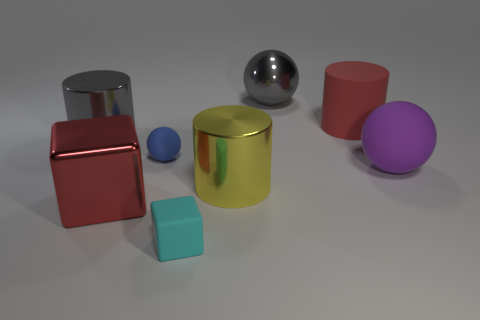Is the number of small rubber spheres that are to the left of the large red metallic thing less than the number of big gray shiny balls that are right of the red cylinder?
Offer a terse response. No. What is the material of the cube on the right side of the blue ball?
Make the answer very short. Rubber. The cylinder that is the same color as the big block is what size?
Provide a short and direct response. Large. Are there any yellow shiny cylinders of the same size as the purple sphere?
Your answer should be very brief. Yes. There is a blue rubber object; does it have the same shape as the gray thing that is left of the tiny blue rubber thing?
Make the answer very short. No. Is the size of the red object behind the large purple matte ball the same as the gray metal thing that is on the left side of the red shiny object?
Offer a terse response. Yes. What number of other things are the same shape as the big purple object?
Keep it short and to the point. 2. What is the material of the object that is behind the big red object that is right of the big yellow metallic thing?
Offer a very short reply. Metal. How many rubber objects are either big blue balls or red objects?
Your answer should be very brief. 1. Is there anything else that has the same material as the purple sphere?
Provide a succinct answer. Yes. 